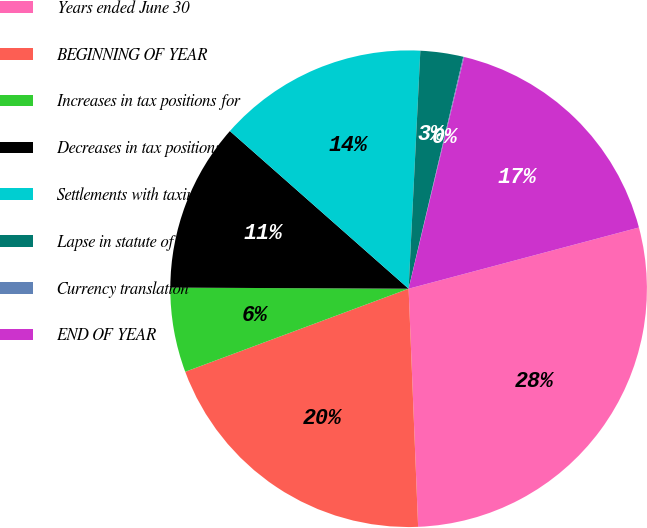<chart> <loc_0><loc_0><loc_500><loc_500><pie_chart><fcel>Years ended June 30<fcel>BEGINNING OF YEAR<fcel>Increases in tax positions for<fcel>Decreases in tax positions for<fcel>Settlements with taxing<fcel>Lapse in statute of<fcel>Currency translation<fcel>END OF YEAR<nl><fcel>28.5%<fcel>19.97%<fcel>5.74%<fcel>11.43%<fcel>14.28%<fcel>2.9%<fcel>0.06%<fcel>17.12%<nl></chart> 